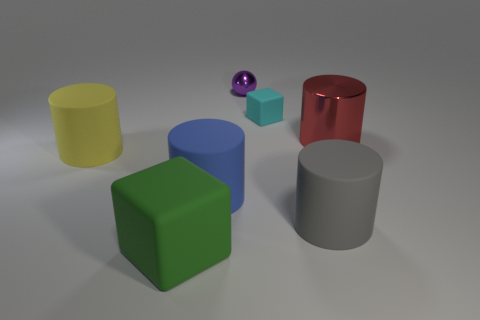What number of objects are either objects that are on the right side of the green object or cylinders that are to the right of the blue matte object?
Keep it short and to the point. 5. Are there any other things that have the same shape as the small purple metallic thing?
Keep it short and to the point. No. How many small green matte things are there?
Provide a succinct answer. 0. Are there any green blocks that have the same size as the cyan object?
Offer a terse response. No. Are the green thing and the large object behind the yellow matte thing made of the same material?
Offer a terse response. No. There is a big object that is to the left of the large matte cube; what is its material?
Provide a short and direct response. Rubber. What is the size of the blue rubber cylinder?
Ensure brevity in your answer.  Large. Does the cube that is behind the yellow rubber thing have the same size as the cylinder to the right of the large gray cylinder?
Offer a terse response. No. What is the size of the other object that is the same shape as the large green rubber object?
Your answer should be compact. Small. There is a red shiny cylinder; does it have the same size as the cube behind the yellow matte object?
Your answer should be compact. No. 